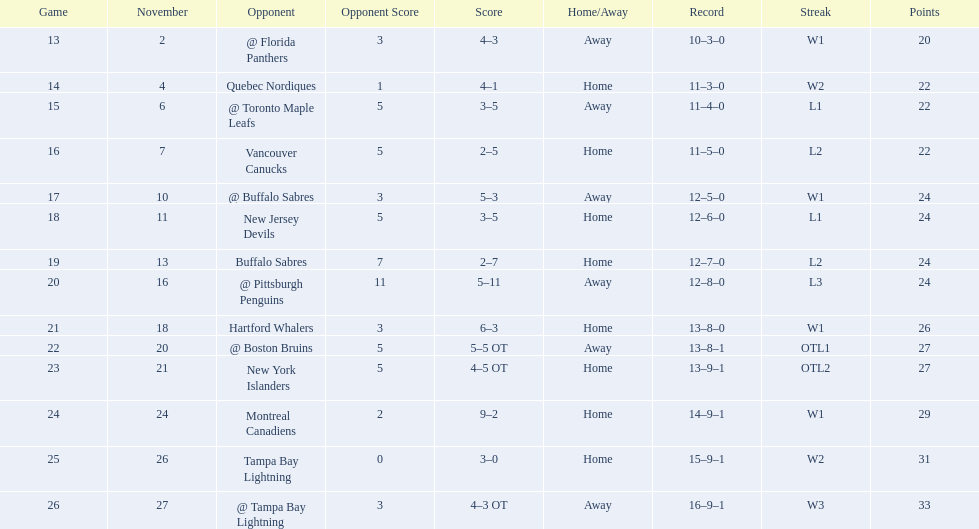Which teams scored 35 points or more in total? Hartford Whalers, @ Boston Bruins, New York Islanders, Montreal Canadiens, Tampa Bay Lightning, @ Tampa Bay Lightning. Of those teams, which team was the only one to score 3-0? Tampa Bay Lightning. 